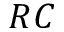<formula> <loc_0><loc_0><loc_500><loc_500>R C</formula> 